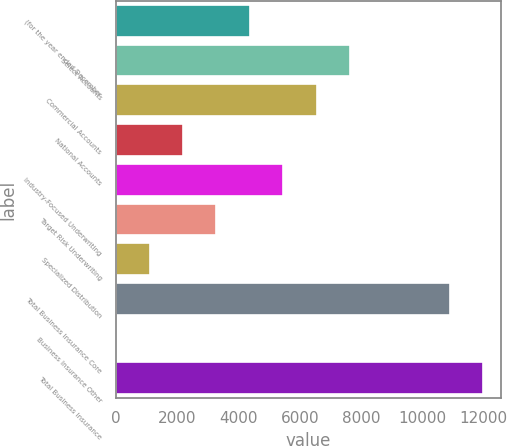<chart> <loc_0><loc_0><loc_500><loc_500><bar_chart><fcel>(for the year ended December<fcel>Select Accounts<fcel>Commercial Accounts<fcel>National Accounts<fcel>Industry-Focused Underwriting<fcel>Target Risk Underwriting<fcel>Specialized Distribution<fcel>Total Business Insurance Core<fcel>Business Insurance Other<fcel>Total Business Insurance<nl><fcel>4369.8<fcel>7635.9<fcel>6547.2<fcel>2192.4<fcel>5458.5<fcel>3281.1<fcel>1103.7<fcel>10887<fcel>15<fcel>11975.7<nl></chart> 